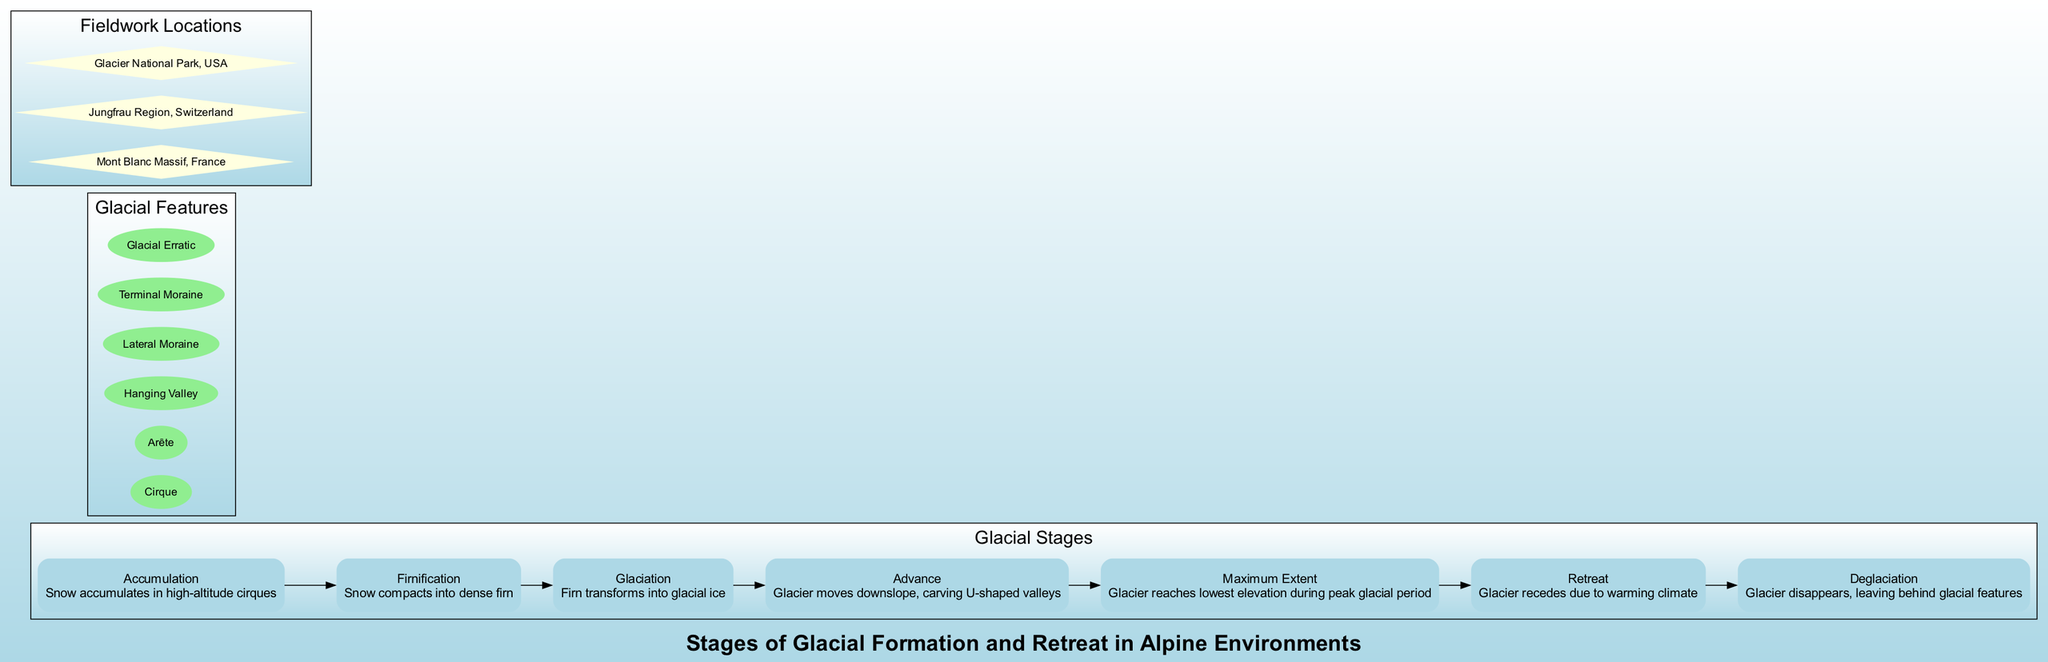What is the first stage of glacial formation? The diagram lists several stages of glacial formation, with the first stage being labeled as "Accumulation." This involves the accumulation of snow in high-altitude cirques.
Answer: Accumulation How many stages are there in total? The diagram displays seven stages of glacial formation and retreat, which can be counted from the enumeration of stages in the subgraph labeled 'Glacial Stages.'
Answer: 7 What stage comes after Firnification? The stage after Firnification is labeled "Glaciation," indicating the transformation of firn into glacial ice. This can be determined by following the sequential flow of the diagram from Firnification to the next node.
Answer: Glaciation Which feature is associated with glacial retreat? While examining the diagram, it does not explicitly state which features correspond with stages, but the process of glacial retreat is related to the concept of deglaciation, where the glacier disappears, leaving glacial features behind. Hence, the most relevant feature could be "Glacial Erratic," as it can remain after retreat.
Answer: Glacial Erratic What is the maximum extent of a glacier? The diagram defines "Maximum Extent" as the stage where the glacier reaches its lowest elevation during the peak of the glacial period, indicating the greatest extent of its advance. This is described directly in the node labeled "Maximum Extent."
Answer: Maximum Extent Which location is noted for geological fieldwork related to glacial studies? The diagram lists multiple fieldwork locations, and "Mont Blanc Massif, France" is one of them, which is well-regarded for geological studies focused on glaciers. This is identified by reading the labels in the subgraph dedicated to fieldwork locations.
Answer: Mont Blanc Massif, France What is the last stage of glacial retreat? According to the diagram, the last stage of glacial retreat is "Deglaciation," indicating that the glacier has entirely disappeared, leaving behind features like moraines and erratics. This is clear from the final node in the flow of stages.
Answer: Deglaciation How does a glacier advance? The diagram indicates that a glacier advances by moving downslope and carving U-shaped valleys, which is explained in the "Advance" stage description. This information can be found in the flow of stages leading to the advance process.
Answer: Moving downslope What shape do the valleys carved by glaciers take? The diagram states that as glaciers advance, they carve U-shaped valleys, which describes the geomorphological impact of glacier movement on the landscape. This information is direct from the description of the "Advance" stage.
Answer: U-shaped 